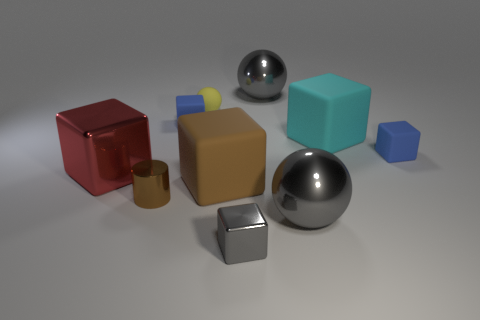What number of things are either big yellow shiny cubes or rubber things on the left side of the large brown matte cube?
Provide a short and direct response. 2. What is the color of the sphere that is made of the same material as the big cyan thing?
Make the answer very short. Yellow. How many large balls have the same material as the red object?
Your answer should be compact. 2. How many tiny blue rubber things are there?
Your answer should be compact. 2. There is a tiny shiny thing that is behind the gray shiny block; does it have the same color as the small matte block that is on the left side of the small gray shiny cube?
Offer a terse response. No. How many tiny brown cylinders are in front of the gray cube?
Provide a short and direct response. 0. There is a thing that is the same color as the cylinder; what is it made of?
Your answer should be very brief. Rubber. Is there a gray metal thing that has the same shape as the brown shiny object?
Your answer should be very brief. No. Is the material of the large block on the left side of the yellow rubber thing the same as the tiny block that is right of the cyan rubber thing?
Provide a succinct answer. No. What is the size of the gray object behind the small blue matte block on the right side of the large gray object behind the red thing?
Keep it short and to the point. Large. 